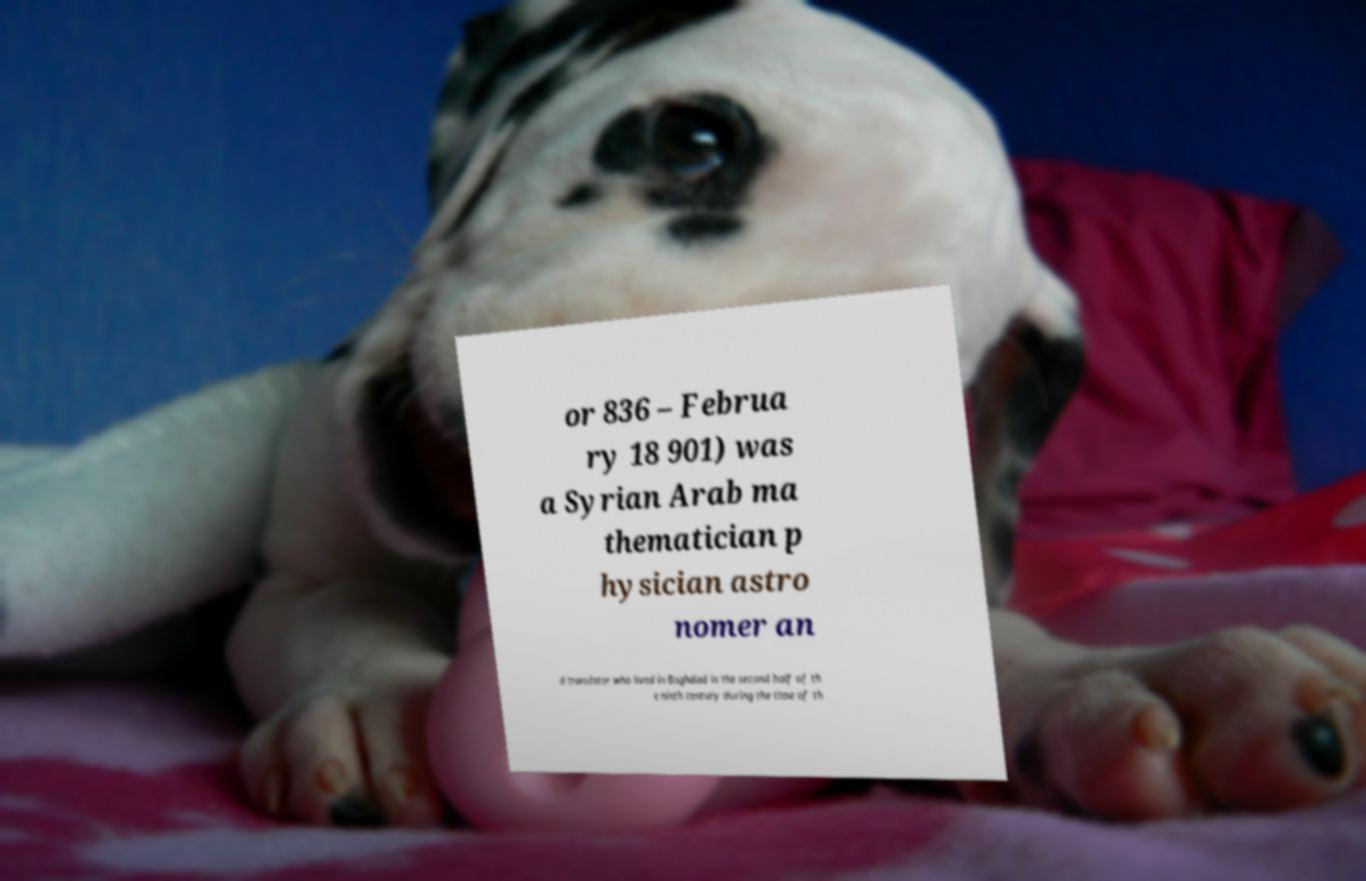Can you read and provide the text displayed in the image?This photo seems to have some interesting text. Can you extract and type it out for me? or 836 – Februa ry 18 901) was a Syrian Arab ma thematician p hysician astro nomer an d translator who lived in Baghdad in the second half of th e ninth century during the time of th 